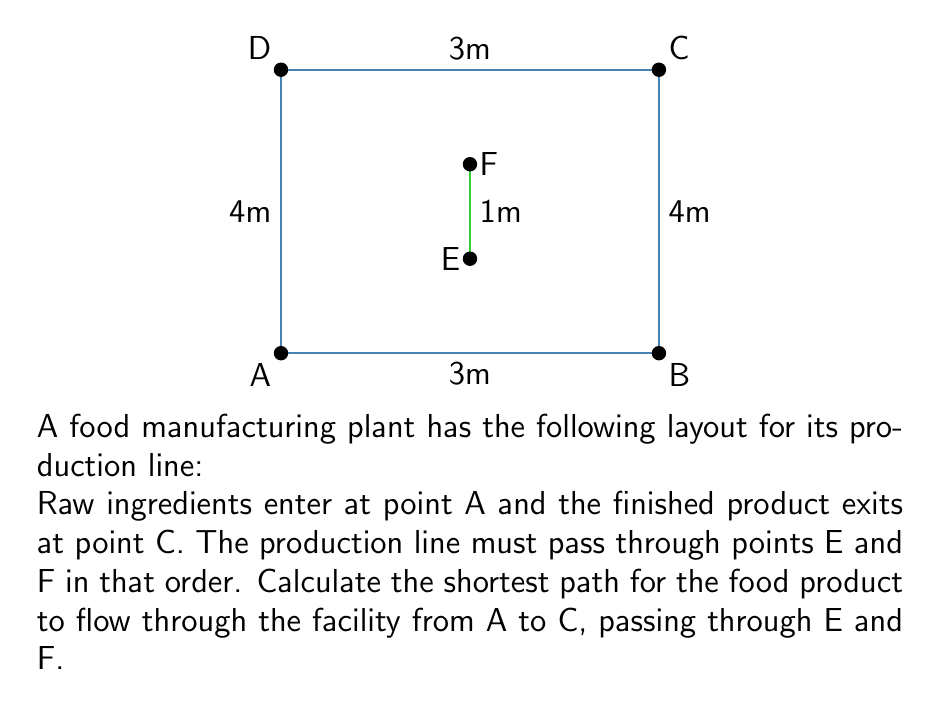Solve this math problem. To solve this problem, we need to find the shortest path from A to C that passes through E and F in that order. We can break this down into three segments: A to E, E to F, and F to C.

1. Segment A to E:
   The shortest path from A to E is a straight line.
   Length AE = $\sqrt{2^2 + 1^2} = \sqrt{5}$ meters

2. Segment E to F:
   This is already a straight vertical line.
   Length EF = 1 meter

3. Segment F to C:
   The shortest path from F to C is a straight line.
   Length FC = $\sqrt{2^2 + 1^2} = \sqrt{5}$ meters

Total shortest path length:
$$L_{total} = AE + EF + FC = \sqrt{5} + 1 + \sqrt{5} = 2\sqrt{5} + 1 \approx 5.47$$ meters

To verify this is indeed the shortest path, we can consider that any deviation from these straight line segments would result in a longer path due to the triangle inequality theorem, which states that the sum of the lengths of any two sides of a triangle must be greater than the length of the remaining side.
Answer: $2\sqrt{5} + 1$ meters 